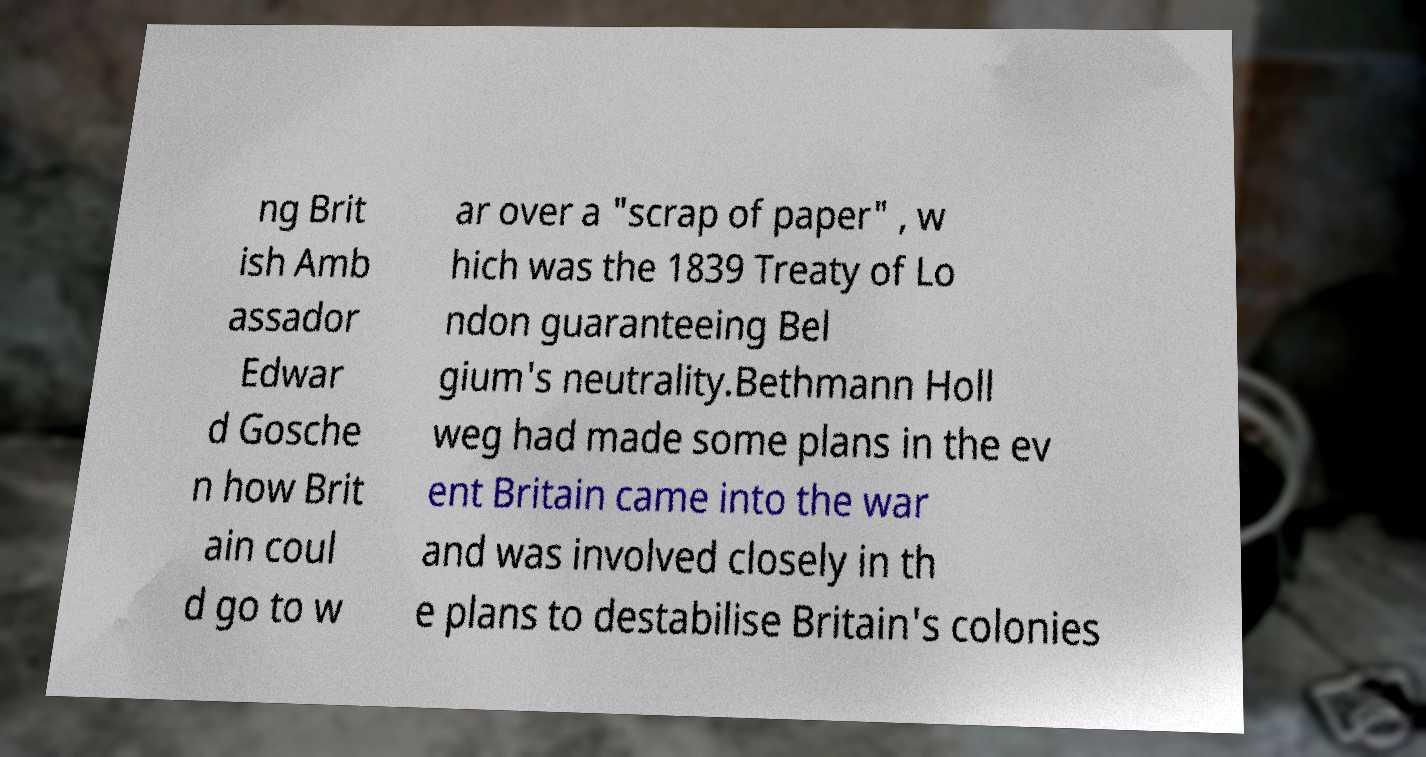What messages or text are displayed in this image? I need them in a readable, typed format. ng Brit ish Amb assador Edwar d Gosche n how Brit ain coul d go to w ar over a "scrap of paper" , w hich was the 1839 Treaty of Lo ndon guaranteeing Bel gium's neutrality.Bethmann Holl weg had made some plans in the ev ent Britain came into the war and was involved closely in th e plans to destabilise Britain's colonies 